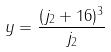Convert formula to latex. <formula><loc_0><loc_0><loc_500><loc_500>y = \frac { ( j _ { 2 } + 1 6 ) ^ { 3 } } { j _ { 2 } }</formula> 